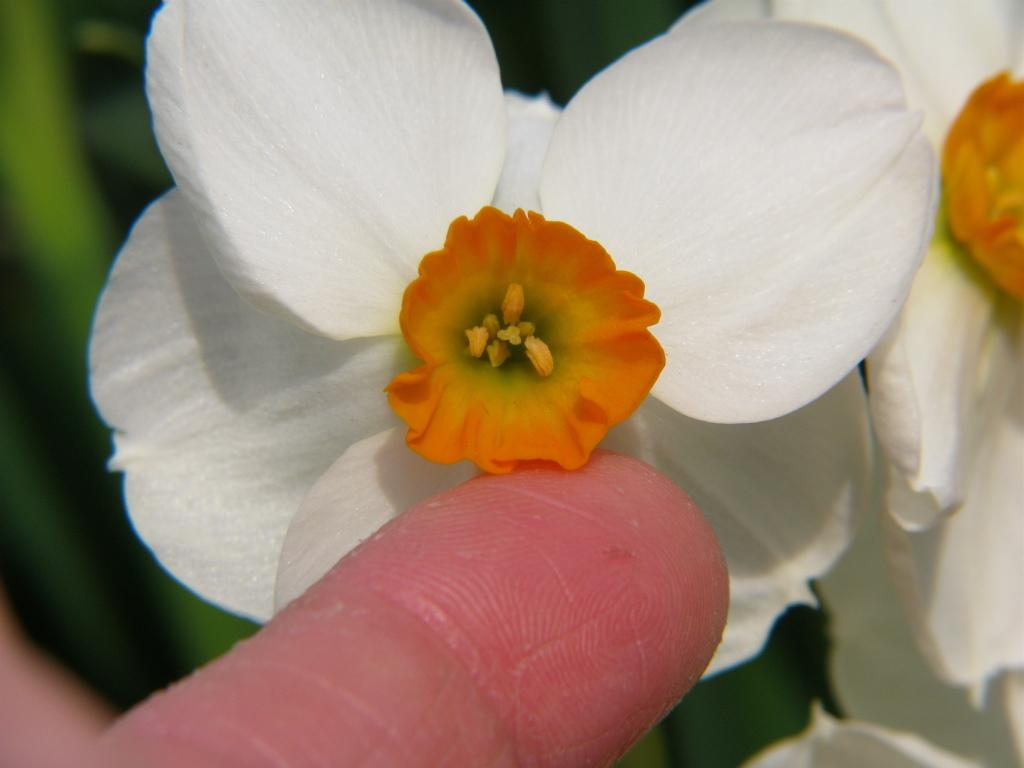What is the main subject of the image? There is a flower in the image. Can you describe the color of the flower? The flower is white in color. Is there anyone else in the image besides the flower? Yes, there is a person in the image. What is the person doing in the image? The person is touching a pollen grain with their finger. What type of polish is the person applying to the flower in the image? There is no indication in the image that the person is applying any polish to the flower. 